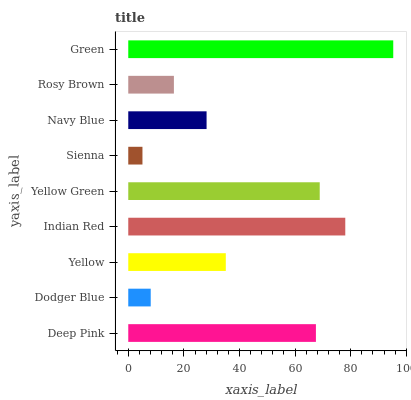Is Sienna the minimum?
Answer yes or no. Yes. Is Green the maximum?
Answer yes or no. Yes. Is Dodger Blue the minimum?
Answer yes or no. No. Is Dodger Blue the maximum?
Answer yes or no. No. Is Deep Pink greater than Dodger Blue?
Answer yes or no. Yes. Is Dodger Blue less than Deep Pink?
Answer yes or no. Yes. Is Dodger Blue greater than Deep Pink?
Answer yes or no. No. Is Deep Pink less than Dodger Blue?
Answer yes or no. No. Is Yellow the high median?
Answer yes or no. Yes. Is Yellow the low median?
Answer yes or no. Yes. Is Yellow Green the high median?
Answer yes or no. No. Is Rosy Brown the low median?
Answer yes or no. No. 